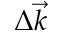Convert formula to latex. <formula><loc_0><loc_0><loc_500><loc_500>\Delta \vec { k }</formula> 